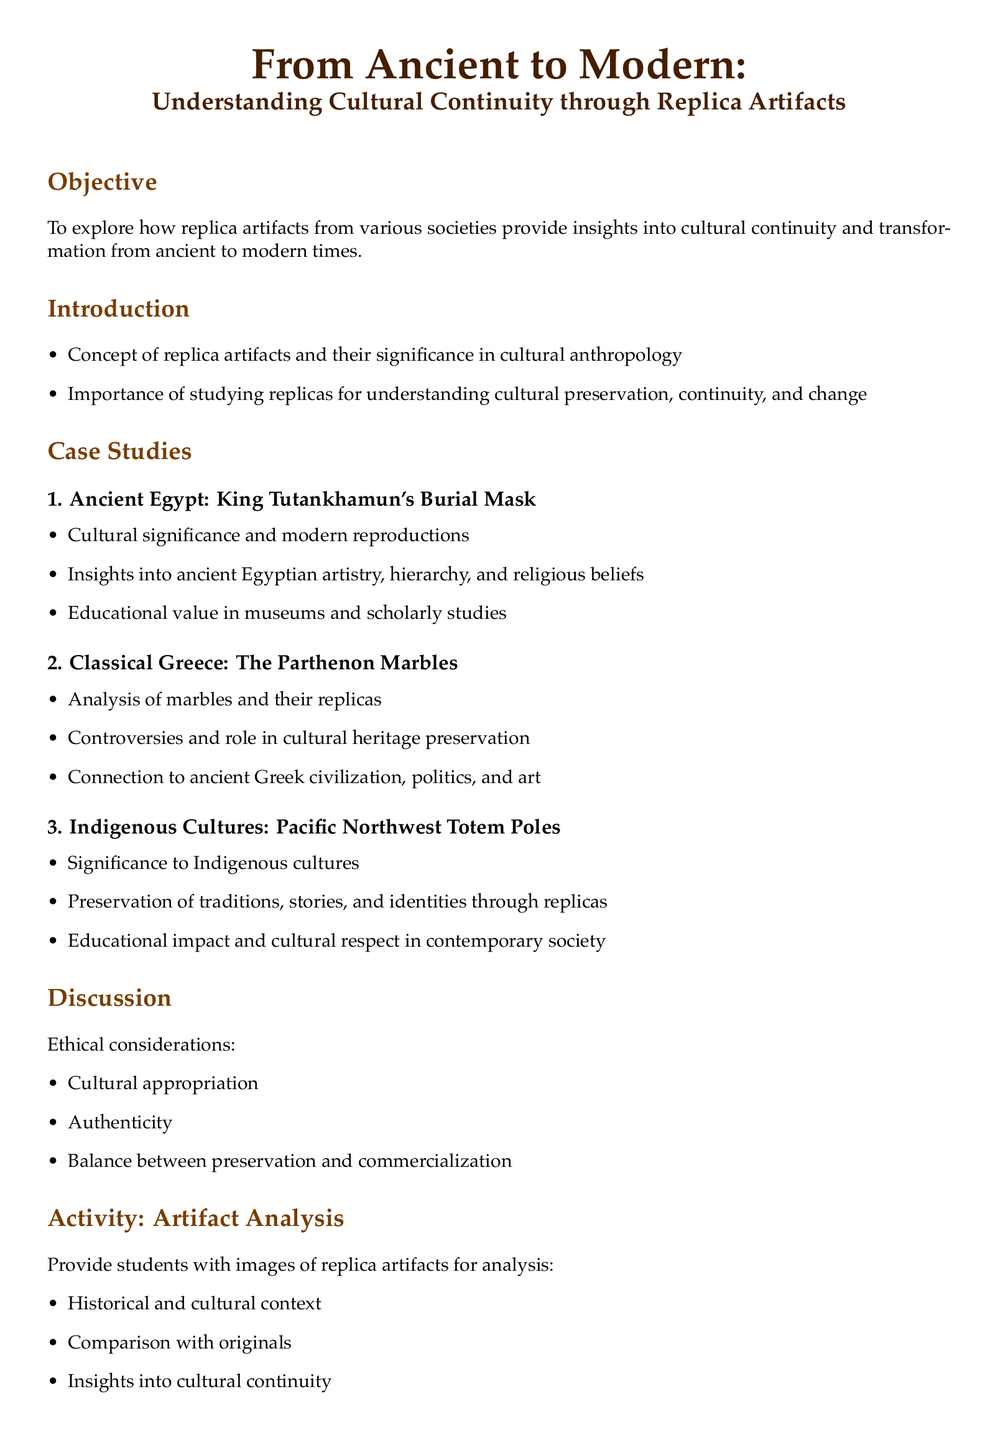What is the title of the lesson plan? The title is presented at the beginning of the document, indicating the topic being covered.
Answer: From Ancient to Modern: Understanding Cultural Continuity through Replica Artifacts What is the first case study mentioned? The case studies section lists Ancient Egypt as the first topic for exploration.
Answer: Ancient Egypt: King Tutankhamun's Burial Mask What cultural significance is discussed regarding totem poles? The document highlights the preservation of traditions, stories, and identities through replicas.
Answer: Preservation of traditions, stories, and identities What ethical considerations are mentioned in the discussion? The ethical considerations are outlined in a bullet point list in the discussion section.
Answer: Cultural appropriation, authenticity, balance between preservation and commercialization What activity is suggested for students? The activity section describes an engagement exercise for students concerning analysis of artifacts.
Answer: Artifact Analysis 